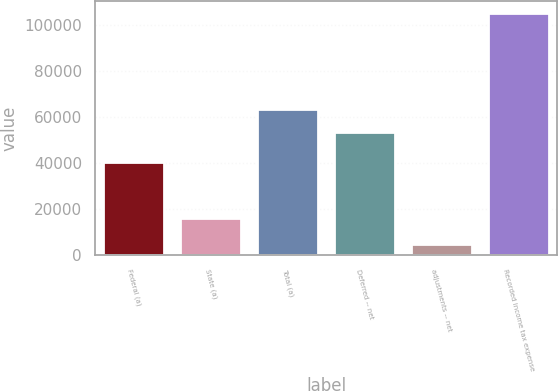<chart> <loc_0><loc_0><loc_500><loc_500><bar_chart><fcel>Federal (a)<fcel>State (a)<fcel>Total (a)<fcel>Deferred -- net<fcel>adjustments -- net<fcel>Recorded income tax expense<nl><fcel>40632<fcel>16306<fcel>63343.5<fcel>53309<fcel>4951<fcel>105296<nl></chart> 